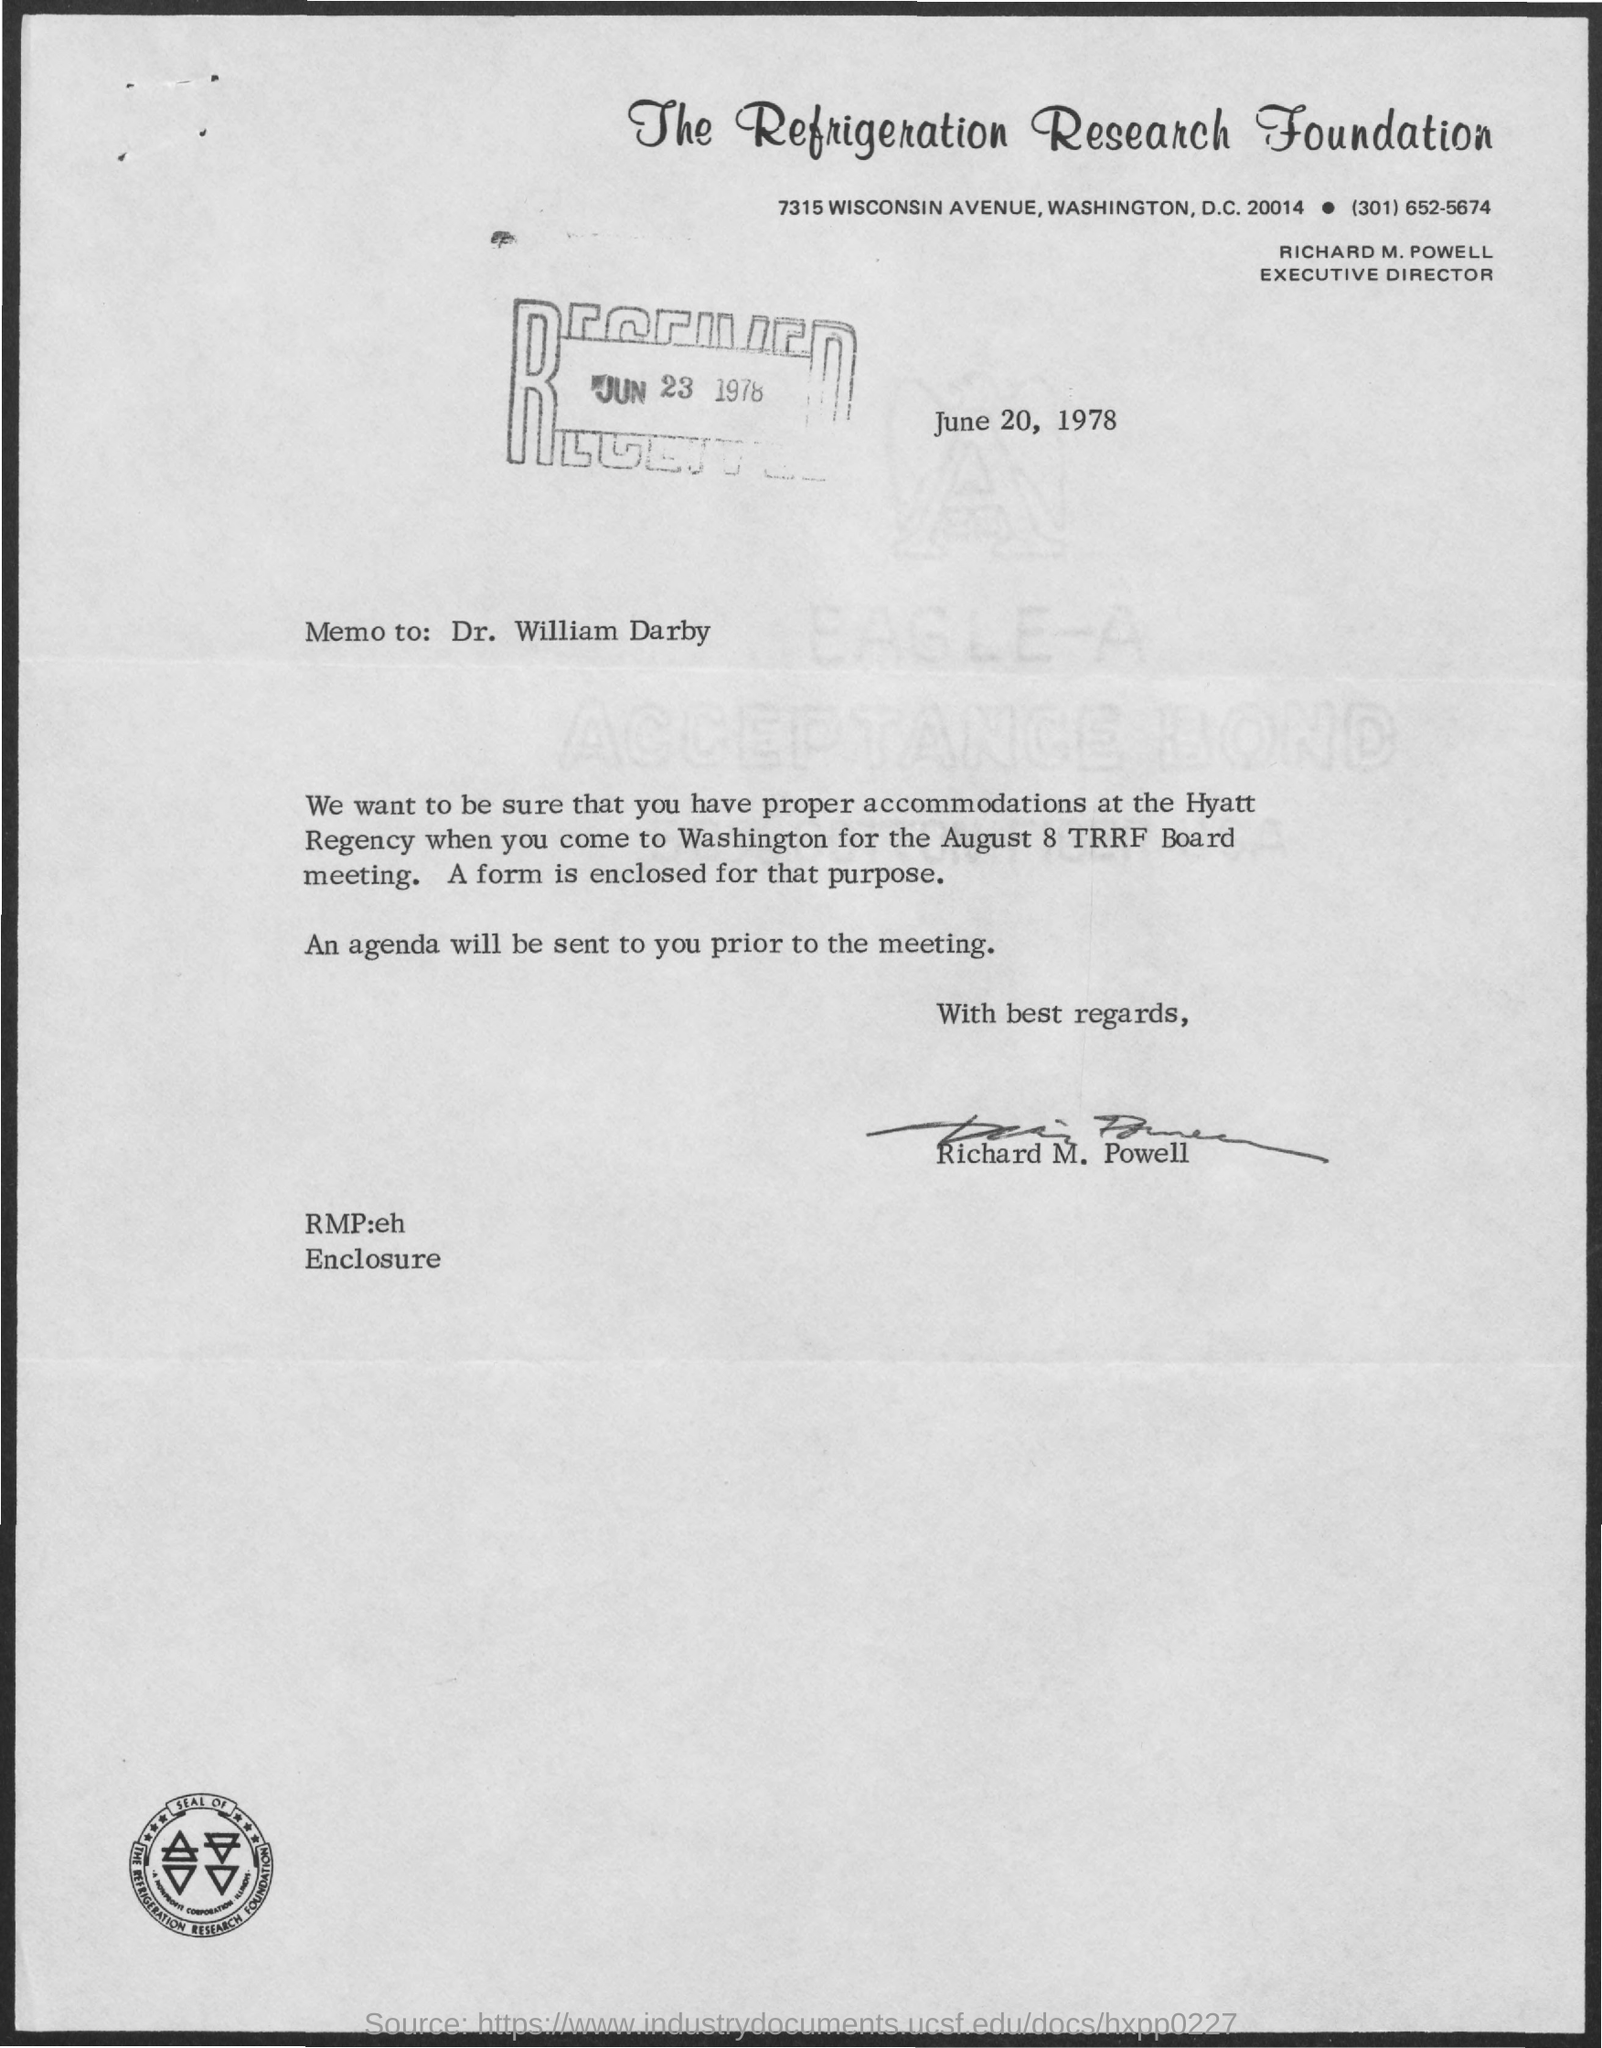What is the name of the foundation mentioned ?
Your answer should be compact. THE REFRIGERATION RESEARCH FOUNDATION. What is the designation of richard m. powell ?
Give a very brief answer. EXECUTIVE DIRECTOR. What is the received date mentioned ?
Your response must be concise. JUN 23 1978. What is the date mentioned in the given page ?
Your response must be concise. JUNE 20, 1978. Who's sign was there at the bottom of the letter ?
Provide a succinct answer. RICHARD M. POWELL. To whom the memo was written ?
Your answer should be compact. DR. WILLIAM DARBY. 